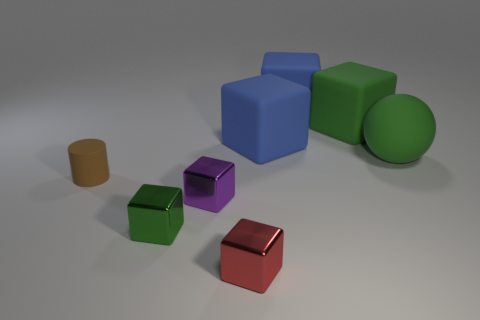Do the red object and the purple metallic cube have the same size?
Your response must be concise. Yes. Is the number of purple blocks that are behind the large green rubber sphere greater than the number of red metal blocks?
Ensure brevity in your answer.  No. What is the size of the brown cylinder that is the same material as the big green cube?
Your answer should be compact. Small. Are there any tiny metal blocks left of the red metallic thing?
Your answer should be very brief. Yes. Is the shape of the small green object the same as the small red object?
Provide a succinct answer. Yes. There is a green object in front of the green rubber object that is right of the green cube that is behind the brown cylinder; how big is it?
Make the answer very short. Small. What material is the red thing?
Offer a very short reply. Metal. There is a matte thing that is the same color as the large matte sphere; what is its size?
Your answer should be very brief. Large. Do the tiny rubber thing and the big green matte object that is on the left side of the green matte ball have the same shape?
Keep it short and to the point. No. There is a green object that is to the left of the tiny thing in front of the tiny metal object left of the small purple shiny thing; what is its material?
Ensure brevity in your answer.  Metal. 